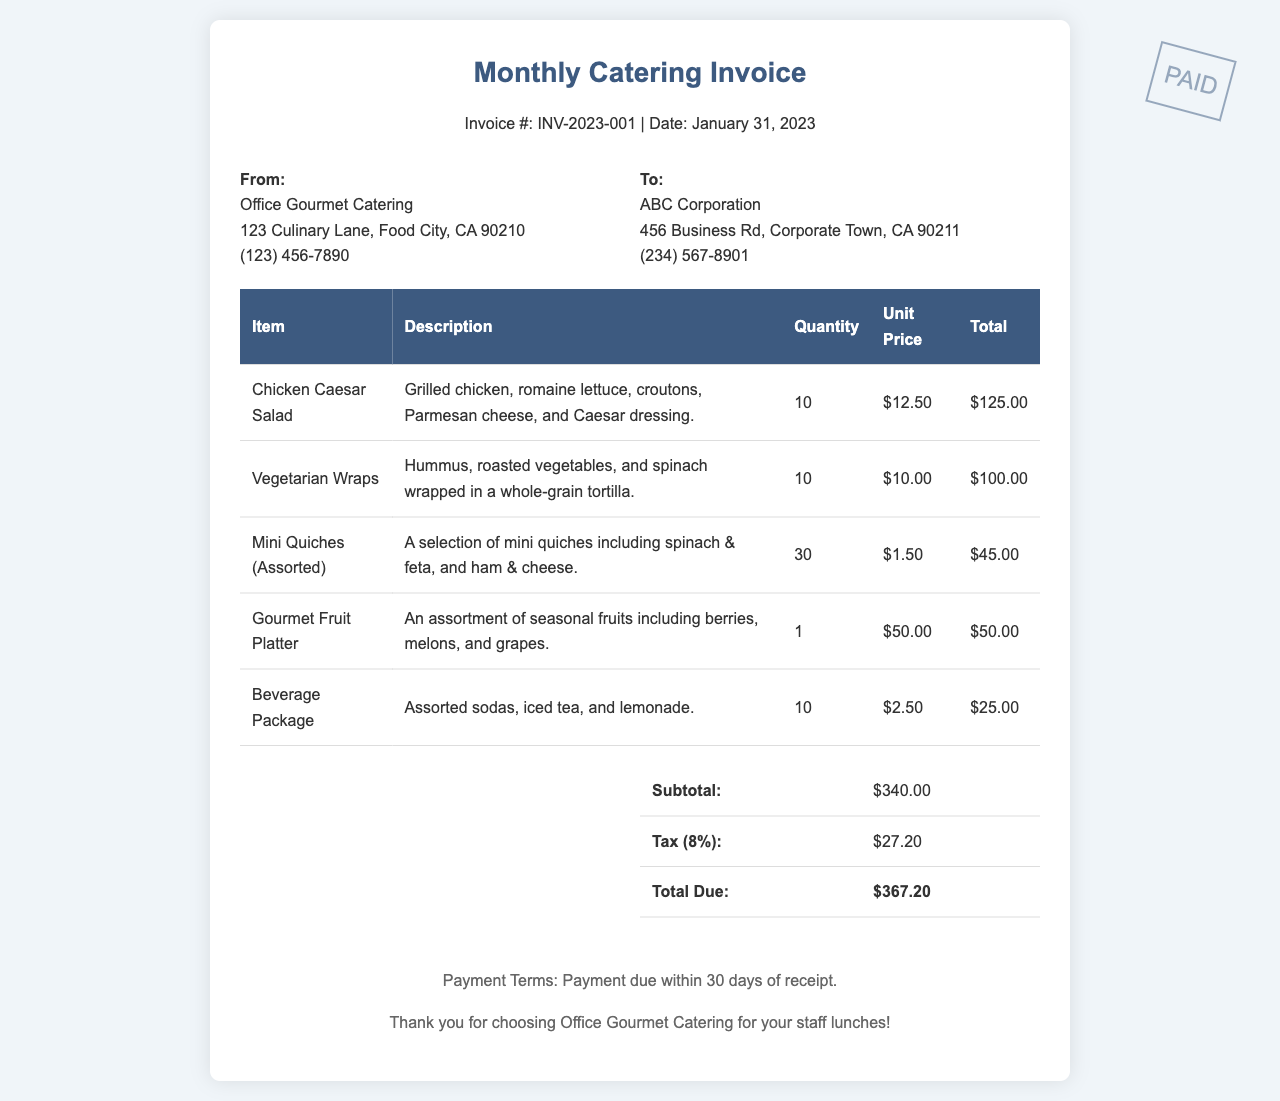What is the invoice number? The invoice number is listed at the top of the document as INV-2023-001.
Answer: INV-2023-001 What is the date of the invoice? The date is provided in the header section, which shows January 31, 2023.
Answer: January 31, 2023 How many Chicken Caesar Salads were ordered? The quantity for Chicken Caesar Salad in the invoice table is 10.
Answer: 10 What is the total due amount? The total due is calculated at the end of the invoice as $367.20.
Answer: $367.20 Who is the catering service provider? The catering service provider is Office Gourmet Catering as stated in the company info section.
Answer: Office Gourmet Catering What percentage is the tax applied? The tax is indicated in the summary section of the invoice as 8%.
Answer: 8% What item has the highest unit price? The item with the highest unit price is the Gourmet Fruit Platter at $50.00.
Answer: Gourmet Fruit Platter What payment terms are specified in the invoice? Payment terms are mentioned in the footer, which states payment due within 30 days of receipt.
Answer: Payment due within 30 days How many Vegetarian Wraps were ordered? The quantity for Vegetarian Wraps is noted in the table as 10.
Answer: 10 What is included in the Beverage Package? The description for the Beverage Package includes assorted sodas, iced tea, and lemonade.
Answer: Assorted sodas, iced tea, and lemonade 